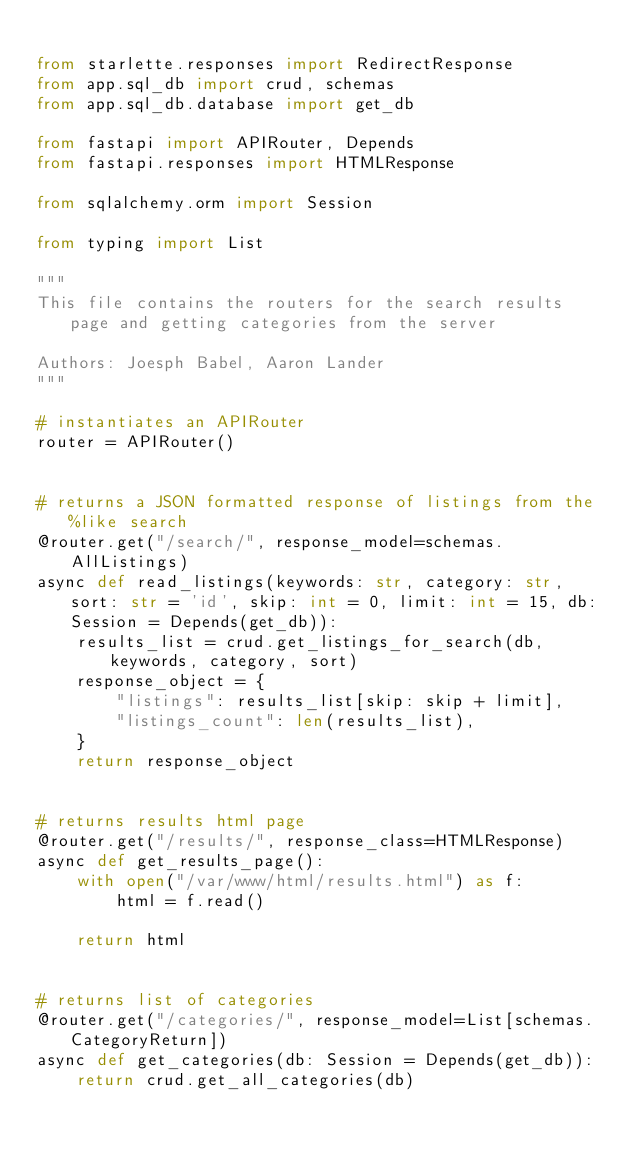Convert code to text. <code><loc_0><loc_0><loc_500><loc_500><_Python_>
from starlette.responses import RedirectResponse
from app.sql_db import crud, schemas
from app.sql_db.database import get_db

from fastapi import APIRouter, Depends
from fastapi.responses import HTMLResponse

from sqlalchemy.orm import Session

from typing import List

"""
This file contains the routers for the search results page and getting categories from the server

Authors: Joesph Babel, Aaron Lander
"""

# instantiates an APIRouter
router = APIRouter()


# returns a JSON formatted response of listings from the %like search
@router.get("/search/", response_model=schemas.AllListings)
async def read_listings(keywords: str, category: str, sort: str = 'id', skip: int = 0, limit: int = 15, db: Session = Depends(get_db)):
    results_list = crud.get_listings_for_search(db, keywords, category, sort)
    response_object = {
        "listings": results_list[skip: skip + limit],
        "listings_count": len(results_list),
    }
    return response_object


# returns results html page
@router.get("/results/", response_class=HTMLResponse)
async def get_results_page():
    with open("/var/www/html/results.html") as f:
        html = f.read()

    return html


# returns list of categories
@router.get("/categories/", response_model=List[schemas.CategoryReturn])
async def get_categories(db: Session = Depends(get_db)):
    return crud.get_all_categories(db)
</code> 